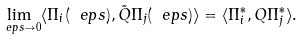<formula> <loc_0><loc_0><loc_500><loc_500>\lim _ { \ e p s \to 0 } \langle \Pi _ { i } ( \ e p s ) , \tilde { Q } \Pi _ { j } ( \ e p s ) \rangle = \langle \Pi _ { i } ^ { * } , Q \Pi _ { j } ^ { * } \rangle .</formula> 